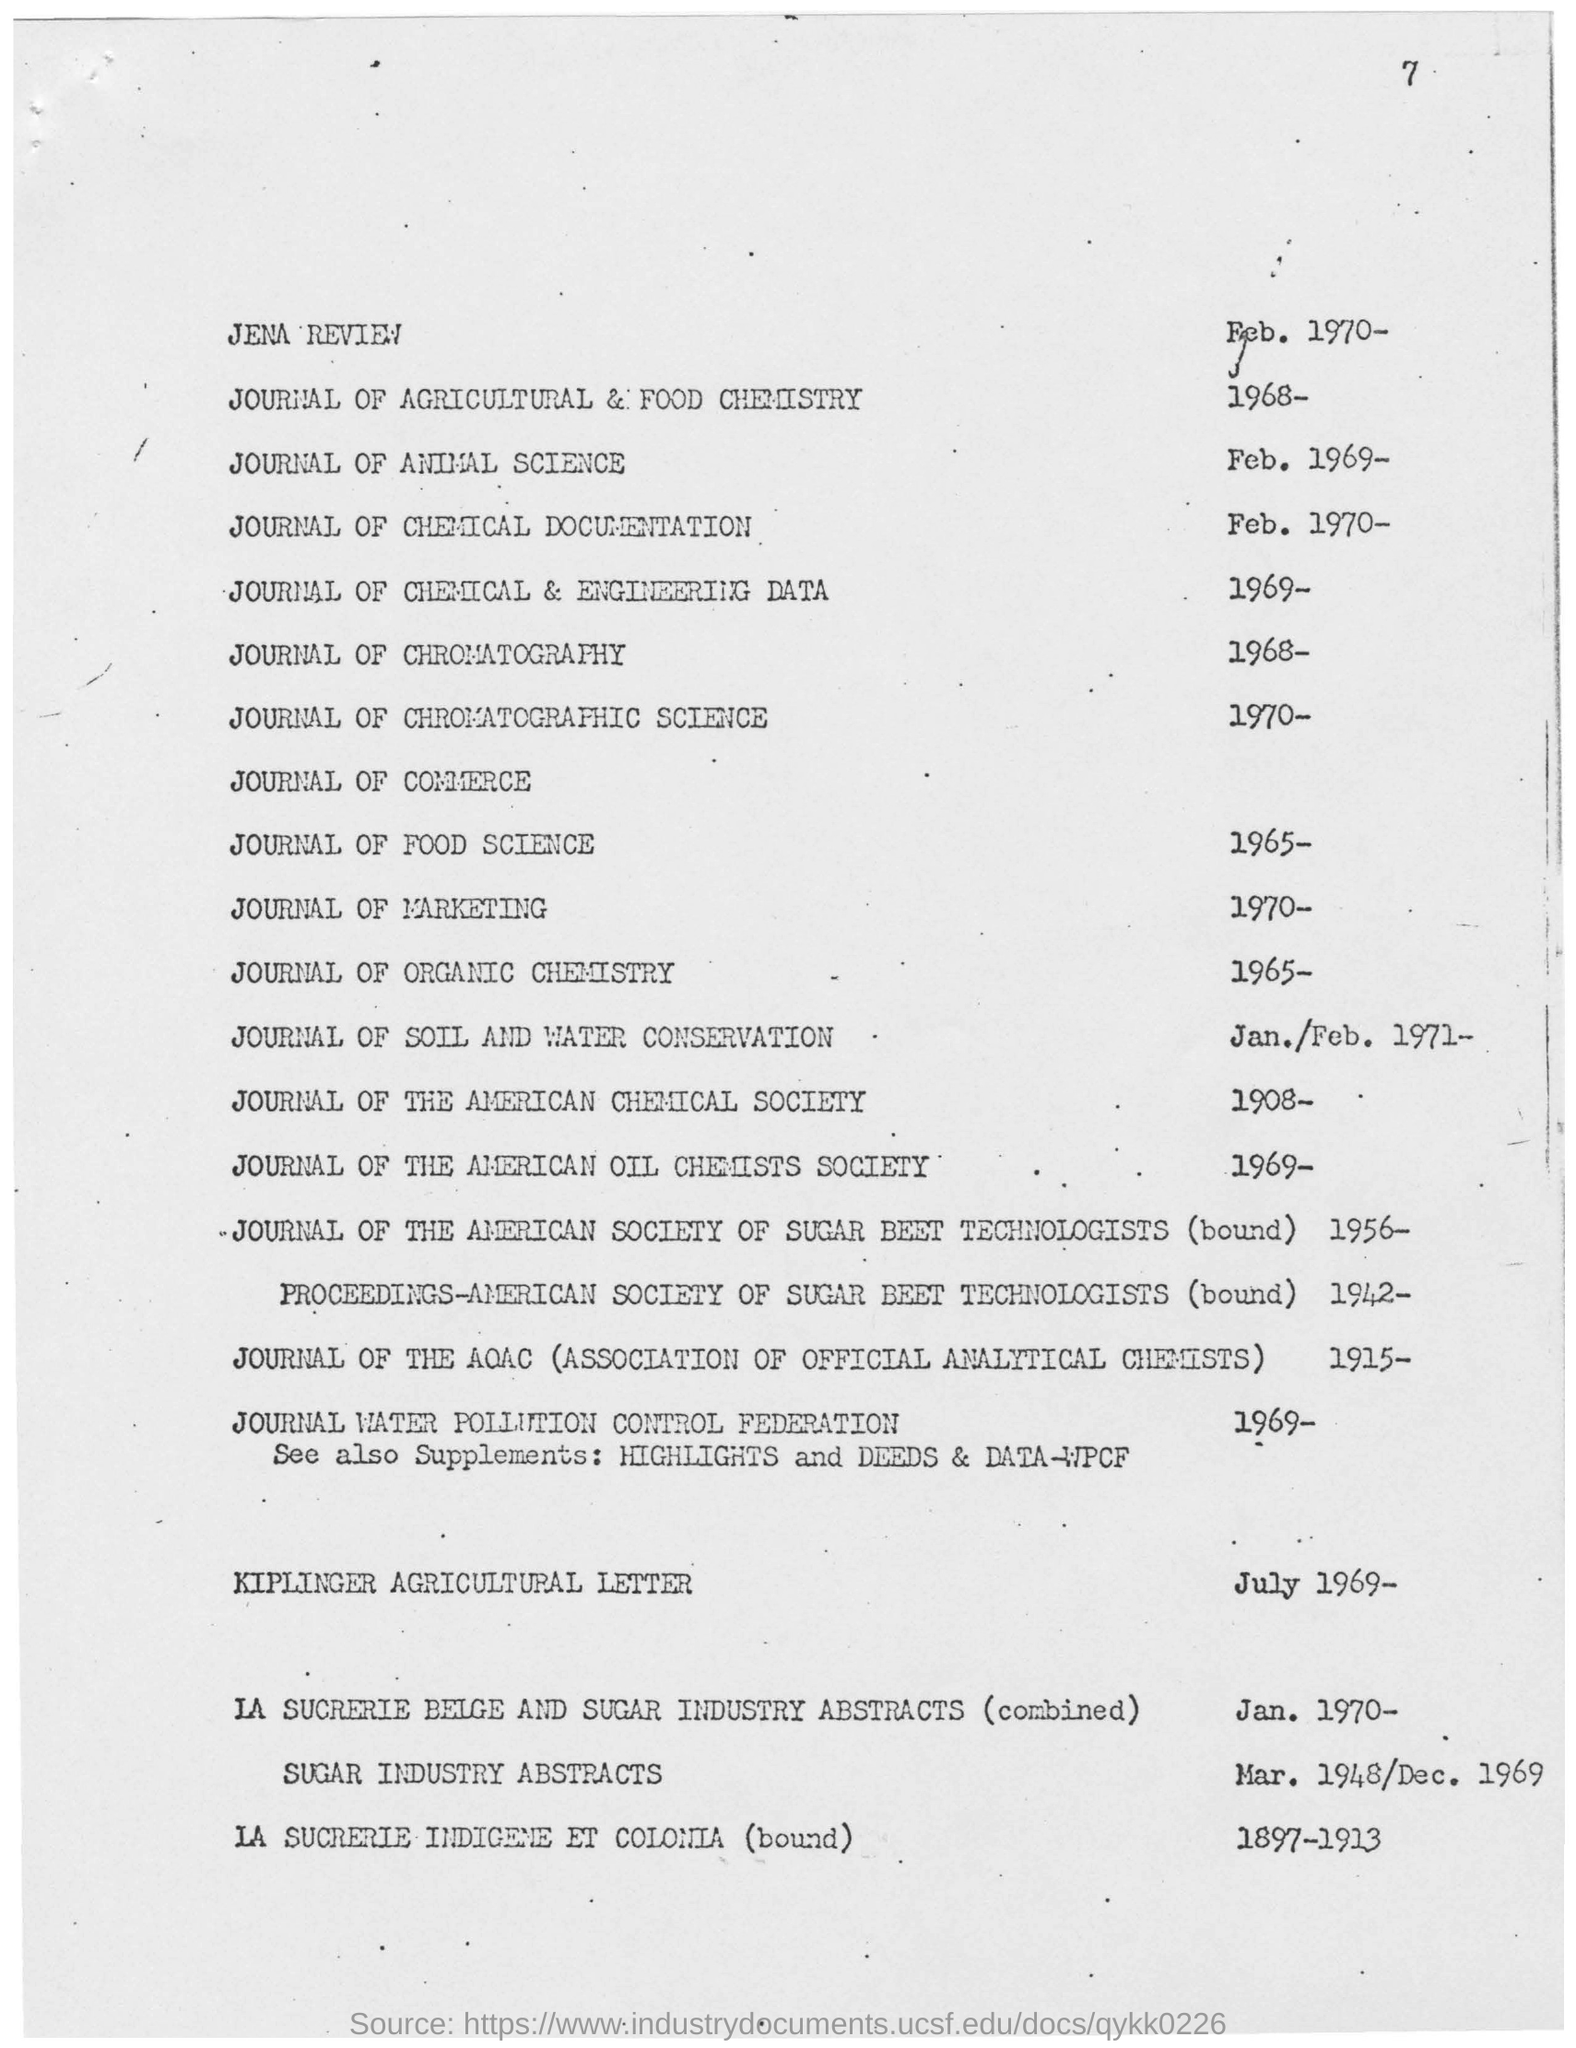When is the Journal of Marketing published?
Your answer should be compact. 1970-. When is Kiplinger Agricultural Letter dated?
Your answer should be very brief. July 1969. What is the name of the fourth Journal listed?
Provide a short and direct response. JOURNAL OF CHEMICAL &  ENGINEERING DATA. 